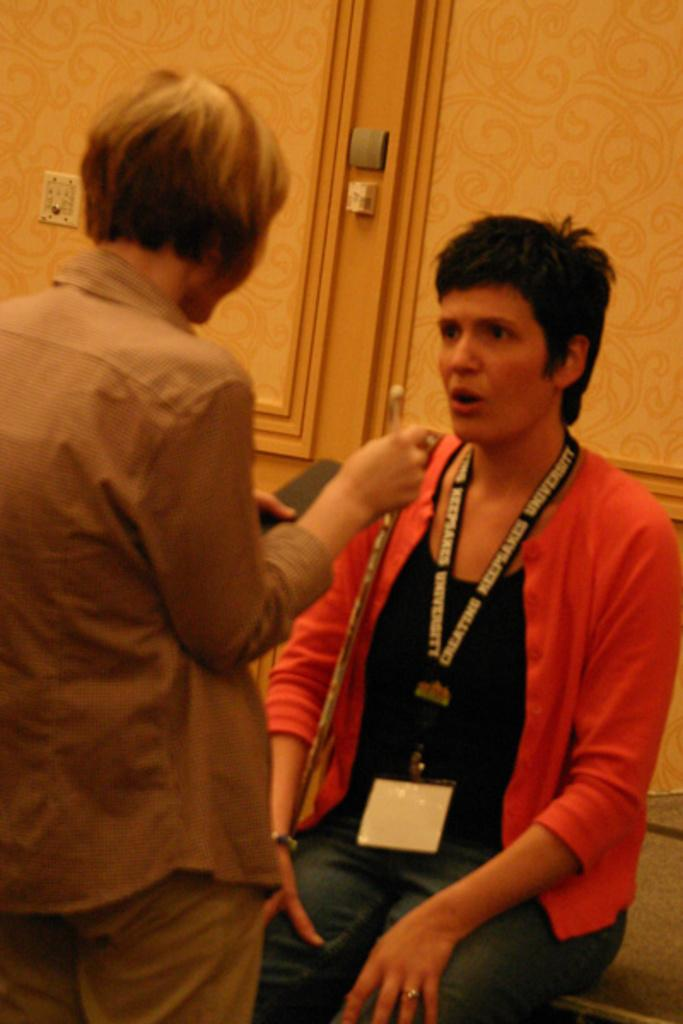How many people are present in the image? There are two people in the image, one standing and one sitting. What is the person on the left side holding? The person on the left side is holding something, but the facts do not specify what it is. What distinguishes the person on the right side? The person on the right side is wearing an identity card. What type of sheet is being used by the person playing basketball in the image? There is no person playing basketball or any sheet present in the image. 